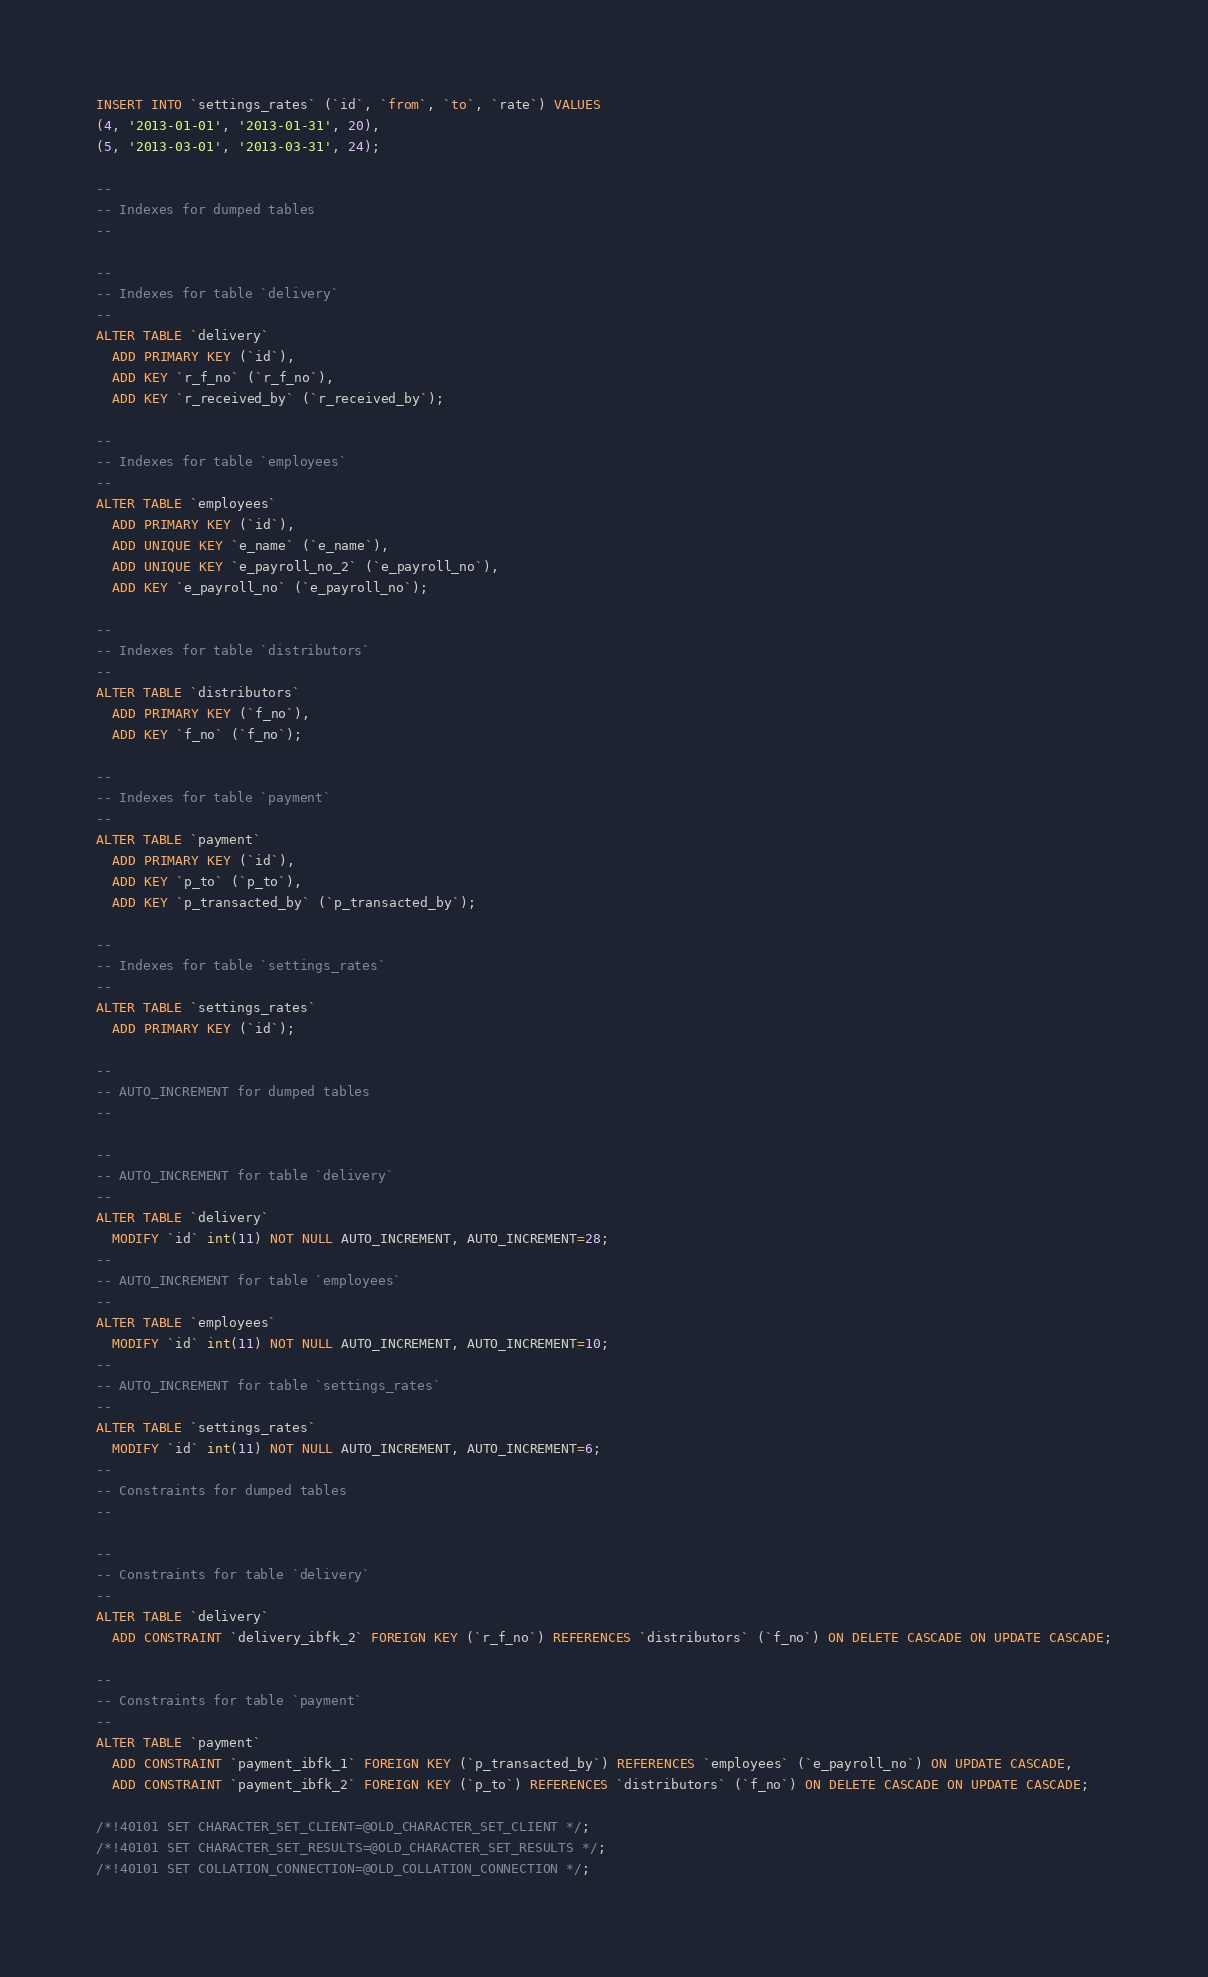Convert code to text. <code><loc_0><loc_0><loc_500><loc_500><_SQL_>INSERT INTO `settings_rates` (`id`, `from`, `to`, `rate`) VALUES
(4, '2013-01-01', '2013-01-31', 20),
(5, '2013-03-01', '2013-03-31', 24);

--
-- Indexes for dumped tables
--

--
-- Indexes for table `delivery`
--
ALTER TABLE `delivery`
  ADD PRIMARY KEY (`id`),
  ADD KEY `r_f_no` (`r_f_no`),
  ADD KEY `r_received_by` (`r_received_by`);

--
-- Indexes for table `employees`
--
ALTER TABLE `employees`
  ADD PRIMARY KEY (`id`),
  ADD UNIQUE KEY `e_name` (`e_name`),
  ADD UNIQUE KEY `e_payroll_no_2` (`e_payroll_no`),
  ADD KEY `e_payroll_no` (`e_payroll_no`);

--
-- Indexes for table `distributors`
--
ALTER TABLE `distributors`
  ADD PRIMARY KEY (`f_no`),
  ADD KEY `f_no` (`f_no`);

--
-- Indexes for table `payment`
--
ALTER TABLE `payment`
  ADD PRIMARY KEY (`id`),
  ADD KEY `p_to` (`p_to`),
  ADD KEY `p_transacted_by` (`p_transacted_by`);

--
-- Indexes for table `settings_rates`
--
ALTER TABLE `settings_rates`
  ADD PRIMARY KEY (`id`);

--
-- AUTO_INCREMENT for dumped tables
--

--
-- AUTO_INCREMENT for table `delivery`
--
ALTER TABLE `delivery`
  MODIFY `id` int(11) NOT NULL AUTO_INCREMENT, AUTO_INCREMENT=28;
--
-- AUTO_INCREMENT for table `employees`
--
ALTER TABLE `employees`
  MODIFY `id` int(11) NOT NULL AUTO_INCREMENT, AUTO_INCREMENT=10;
--
-- AUTO_INCREMENT for table `settings_rates`
--
ALTER TABLE `settings_rates`
  MODIFY `id` int(11) NOT NULL AUTO_INCREMENT, AUTO_INCREMENT=6;
--
-- Constraints for dumped tables
--

--
-- Constraints for table `delivery`
--
ALTER TABLE `delivery`
  ADD CONSTRAINT `delivery_ibfk_2` FOREIGN KEY (`r_f_no`) REFERENCES `distributors` (`f_no`) ON DELETE CASCADE ON UPDATE CASCADE;

--
-- Constraints for table `payment`
--
ALTER TABLE `payment`
  ADD CONSTRAINT `payment_ibfk_1` FOREIGN KEY (`p_transacted_by`) REFERENCES `employees` (`e_payroll_no`) ON UPDATE CASCADE,
  ADD CONSTRAINT `payment_ibfk_2` FOREIGN KEY (`p_to`) REFERENCES `distributors` (`f_no`) ON DELETE CASCADE ON UPDATE CASCADE;

/*!40101 SET CHARACTER_SET_CLIENT=@OLD_CHARACTER_SET_CLIENT */;
/*!40101 SET CHARACTER_SET_RESULTS=@OLD_CHARACTER_SET_RESULTS */;
/*!40101 SET COLLATION_CONNECTION=@OLD_COLLATION_CONNECTION */;
</code> 